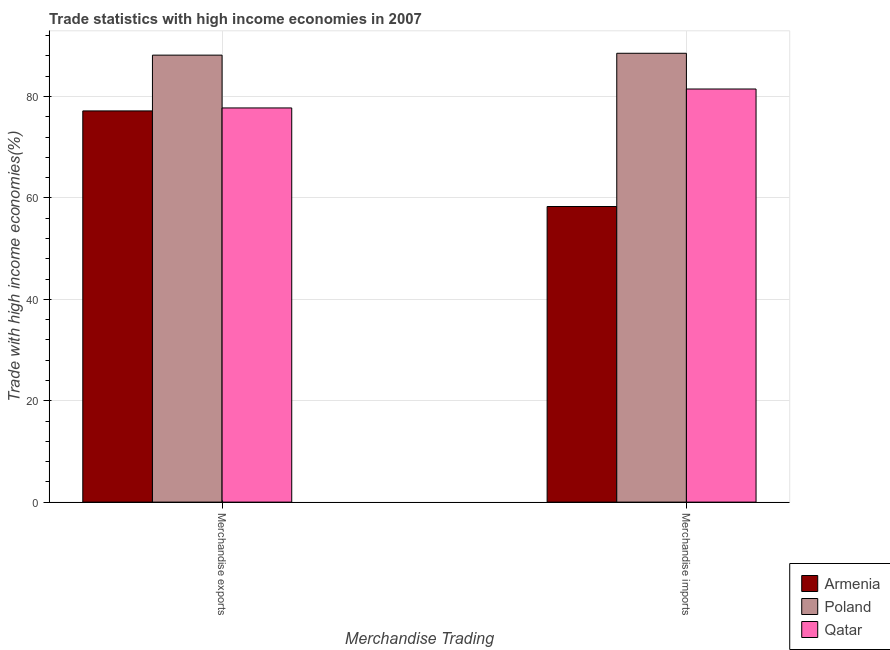How many groups of bars are there?
Give a very brief answer. 2. Are the number of bars per tick equal to the number of legend labels?
Give a very brief answer. Yes. Are the number of bars on each tick of the X-axis equal?
Your response must be concise. Yes. How many bars are there on the 2nd tick from the left?
Offer a terse response. 3. What is the merchandise imports in Qatar?
Your answer should be very brief. 81.49. Across all countries, what is the maximum merchandise imports?
Provide a succinct answer. 88.54. Across all countries, what is the minimum merchandise exports?
Offer a terse response. 77.17. In which country was the merchandise exports maximum?
Give a very brief answer. Poland. In which country was the merchandise exports minimum?
Your answer should be compact. Armenia. What is the total merchandise imports in the graph?
Your answer should be compact. 228.34. What is the difference between the merchandise exports in Qatar and that in Armenia?
Give a very brief answer. 0.58. What is the difference between the merchandise imports in Qatar and the merchandise exports in Armenia?
Your response must be concise. 4.32. What is the average merchandise imports per country?
Make the answer very short. 76.11. What is the difference between the merchandise imports and merchandise exports in Armenia?
Offer a terse response. -18.86. In how many countries, is the merchandise exports greater than 20 %?
Offer a very short reply. 3. What is the ratio of the merchandise imports in Qatar to that in Poland?
Provide a short and direct response. 0.92. Is the merchandise imports in Qatar less than that in Poland?
Provide a succinct answer. Yes. In how many countries, is the merchandise exports greater than the average merchandise exports taken over all countries?
Your answer should be compact. 1. What does the 1st bar from the left in Merchandise exports represents?
Your answer should be compact. Armenia. What does the 1st bar from the right in Merchandise exports represents?
Provide a short and direct response. Qatar. Are all the bars in the graph horizontal?
Ensure brevity in your answer.  No. What is the difference between two consecutive major ticks on the Y-axis?
Offer a very short reply. 20. Does the graph contain any zero values?
Offer a very short reply. No. Does the graph contain grids?
Provide a short and direct response. Yes. Where does the legend appear in the graph?
Offer a very short reply. Bottom right. What is the title of the graph?
Offer a terse response. Trade statistics with high income economies in 2007. What is the label or title of the X-axis?
Make the answer very short. Merchandise Trading. What is the label or title of the Y-axis?
Ensure brevity in your answer.  Trade with high income economies(%). What is the Trade with high income economies(%) in Armenia in Merchandise exports?
Ensure brevity in your answer.  77.17. What is the Trade with high income economies(%) of Poland in Merchandise exports?
Keep it short and to the point. 88.17. What is the Trade with high income economies(%) of Qatar in Merchandise exports?
Ensure brevity in your answer.  77.75. What is the Trade with high income economies(%) in Armenia in Merchandise imports?
Ensure brevity in your answer.  58.31. What is the Trade with high income economies(%) of Poland in Merchandise imports?
Your response must be concise. 88.54. What is the Trade with high income economies(%) in Qatar in Merchandise imports?
Provide a succinct answer. 81.49. Across all Merchandise Trading, what is the maximum Trade with high income economies(%) of Armenia?
Offer a terse response. 77.17. Across all Merchandise Trading, what is the maximum Trade with high income economies(%) of Poland?
Keep it short and to the point. 88.54. Across all Merchandise Trading, what is the maximum Trade with high income economies(%) of Qatar?
Your answer should be very brief. 81.49. Across all Merchandise Trading, what is the minimum Trade with high income economies(%) of Armenia?
Offer a terse response. 58.31. Across all Merchandise Trading, what is the minimum Trade with high income economies(%) in Poland?
Keep it short and to the point. 88.17. Across all Merchandise Trading, what is the minimum Trade with high income economies(%) in Qatar?
Your answer should be very brief. 77.75. What is the total Trade with high income economies(%) in Armenia in the graph?
Your answer should be very brief. 135.48. What is the total Trade with high income economies(%) in Poland in the graph?
Give a very brief answer. 176.71. What is the total Trade with high income economies(%) of Qatar in the graph?
Provide a succinct answer. 159.24. What is the difference between the Trade with high income economies(%) of Armenia in Merchandise exports and that in Merchandise imports?
Keep it short and to the point. 18.86. What is the difference between the Trade with high income economies(%) of Poland in Merchandise exports and that in Merchandise imports?
Keep it short and to the point. -0.37. What is the difference between the Trade with high income economies(%) of Qatar in Merchandise exports and that in Merchandise imports?
Ensure brevity in your answer.  -3.74. What is the difference between the Trade with high income economies(%) in Armenia in Merchandise exports and the Trade with high income economies(%) in Poland in Merchandise imports?
Make the answer very short. -11.37. What is the difference between the Trade with high income economies(%) of Armenia in Merchandise exports and the Trade with high income economies(%) of Qatar in Merchandise imports?
Your answer should be very brief. -4.32. What is the difference between the Trade with high income economies(%) of Poland in Merchandise exports and the Trade with high income economies(%) of Qatar in Merchandise imports?
Your response must be concise. 6.68. What is the average Trade with high income economies(%) of Armenia per Merchandise Trading?
Ensure brevity in your answer.  67.74. What is the average Trade with high income economies(%) in Poland per Merchandise Trading?
Your response must be concise. 88.36. What is the average Trade with high income economies(%) of Qatar per Merchandise Trading?
Keep it short and to the point. 79.62. What is the difference between the Trade with high income economies(%) in Armenia and Trade with high income economies(%) in Poland in Merchandise exports?
Keep it short and to the point. -11. What is the difference between the Trade with high income economies(%) in Armenia and Trade with high income economies(%) in Qatar in Merchandise exports?
Your answer should be very brief. -0.58. What is the difference between the Trade with high income economies(%) of Poland and Trade with high income economies(%) of Qatar in Merchandise exports?
Provide a succinct answer. 10.42. What is the difference between the Trade with high income economies(%) in Armenia and Trade with high income economies(%) in Poland in Merchandise imports?
Offer a very short reply. -30.23. What is the difference between the Trade with high income economies(%) of Armenia and Trade with high income economies(%) of Qatar in Merchandise imports?
Offer a very short reply. -23.18. What is the difference between the Trade with high income economies(%) in Poland and Trade with high income economies(%) in Qatar in Merchandise imports?
Your answer should be compact. 7.05. What is the ratio of the Trade with high income economies(%) in Armenia in Merchandise exports to that in Merchandise imports?
Your answer should be very brief. 1.32. What is the ratio of the Trade with high income economies(%) in Poland in Merchandise exports to that in Merchandise imports?
Provide a succinct answer. 1. What is the ratio of the Trade with high income economies(%) in Qatar in Merchandise exports to that in Merchandise imports?
Your response must be concise. 0.95. What is the difference between the highest and the second highest Trade with high income economies(%) of Armenia?
Offer a very short reply. 18.86. What is the difference between the highest and the second highest Trade with high income economies(%) in Poland?
Offer a very short reply. 0.37. What is the difference between the highest and the second highest Trade with high income economies(%) in Qatar?
Provide a short and direct response. 3.74. What is the difference between the highest and the lowest Trade with high income economies(%) in Armenia?
Make the answer very short. 18.86. What is the difference between the highest and the lowest Trade with high income economies(%) in Poland?
Your answer should be compact. 0.37. What is the difference between the highest and the lowest Trade with high income economies(%) of Qatar?
Give a very brief answer. 3.74. 